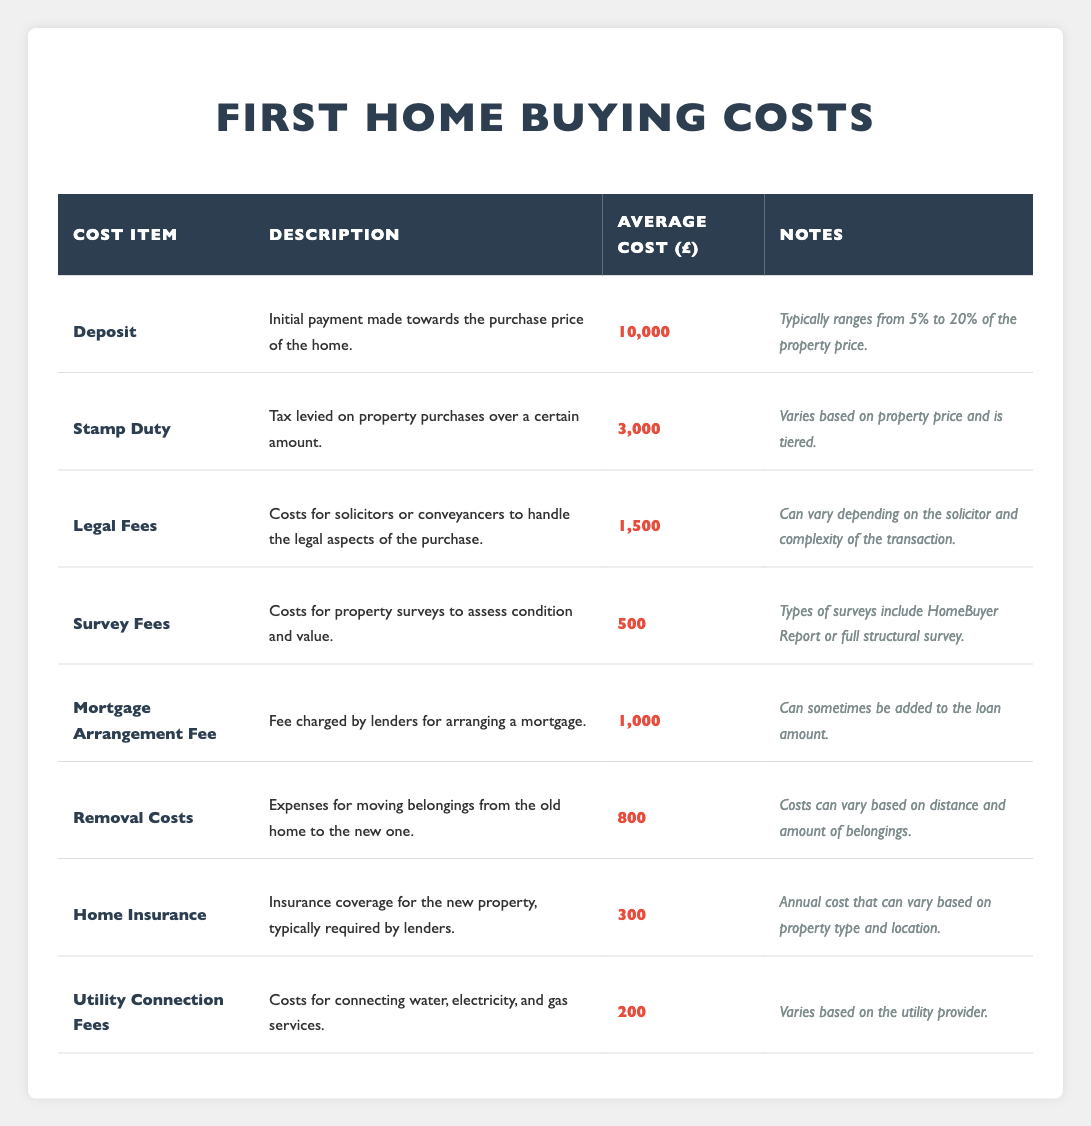What is the average cost of the Deposit? The average cost of the Deposit is given in the table as 10,000.
Answer: 10,000 What is the cost item associated with legal fees? The cost item associated with legal fees is listed as "Legal Fees" in the table.
Answer: Legal Fees How much does Home Insurance typically cost? The average cost for Home Insurance, as stated in the table, is 300.
Answer: 300 What are the average costs of Stamp Duty and Legal Fees combined? The average costs of Stamp Duty (3,000) and Legal Fees (1,500) sum up to 4,500.
Answer: 4,500 What cost is incurred for connecting utilities? The table shows that Utility Connection Fees incur a cost of 200.
Answer: 200 Is the average cost of Survey Fees higher than that of Home Insurance? The average cost of Survey Fees is 500, which is higher than Home Insurance at 300, so the statement is true.
Answer: Yes What is the total cost for the Deposit, Stamp Duty, and Survey Fees? Adding the average costs: Deposit (10,000) + Stamp Duty (3,000) + Survey Fees (500) equals 13,500.
Answer: 13,500 Which costs are typically variable based on property price or complexity? The costs that vary are Stamp Duty (based on property price), Legal Fees (based on complexity), and Removal Costs (based on distance and belongings), as noted in the table.
Answer: Stamp Duty, Legal Fees, Removal Costs If I save an additional 1,000, what will the total savings be towards the average costs listed? The current average costs total 10,000 + 3,000 + 1,500 + 500 + 1,000 + 800 + 300 + 200 = 17,300. Adding the additional 1,000 gives a total of 18,300.
Answer: 18,300 Is the average cost of Mortgage Arrangement Fee lower than that of Removal Costs? The average cost of Mortgage Arrangement Fee is 1,000, which is lower than Removal Costs at 800; therefore, the statement is false.
Answer: No 